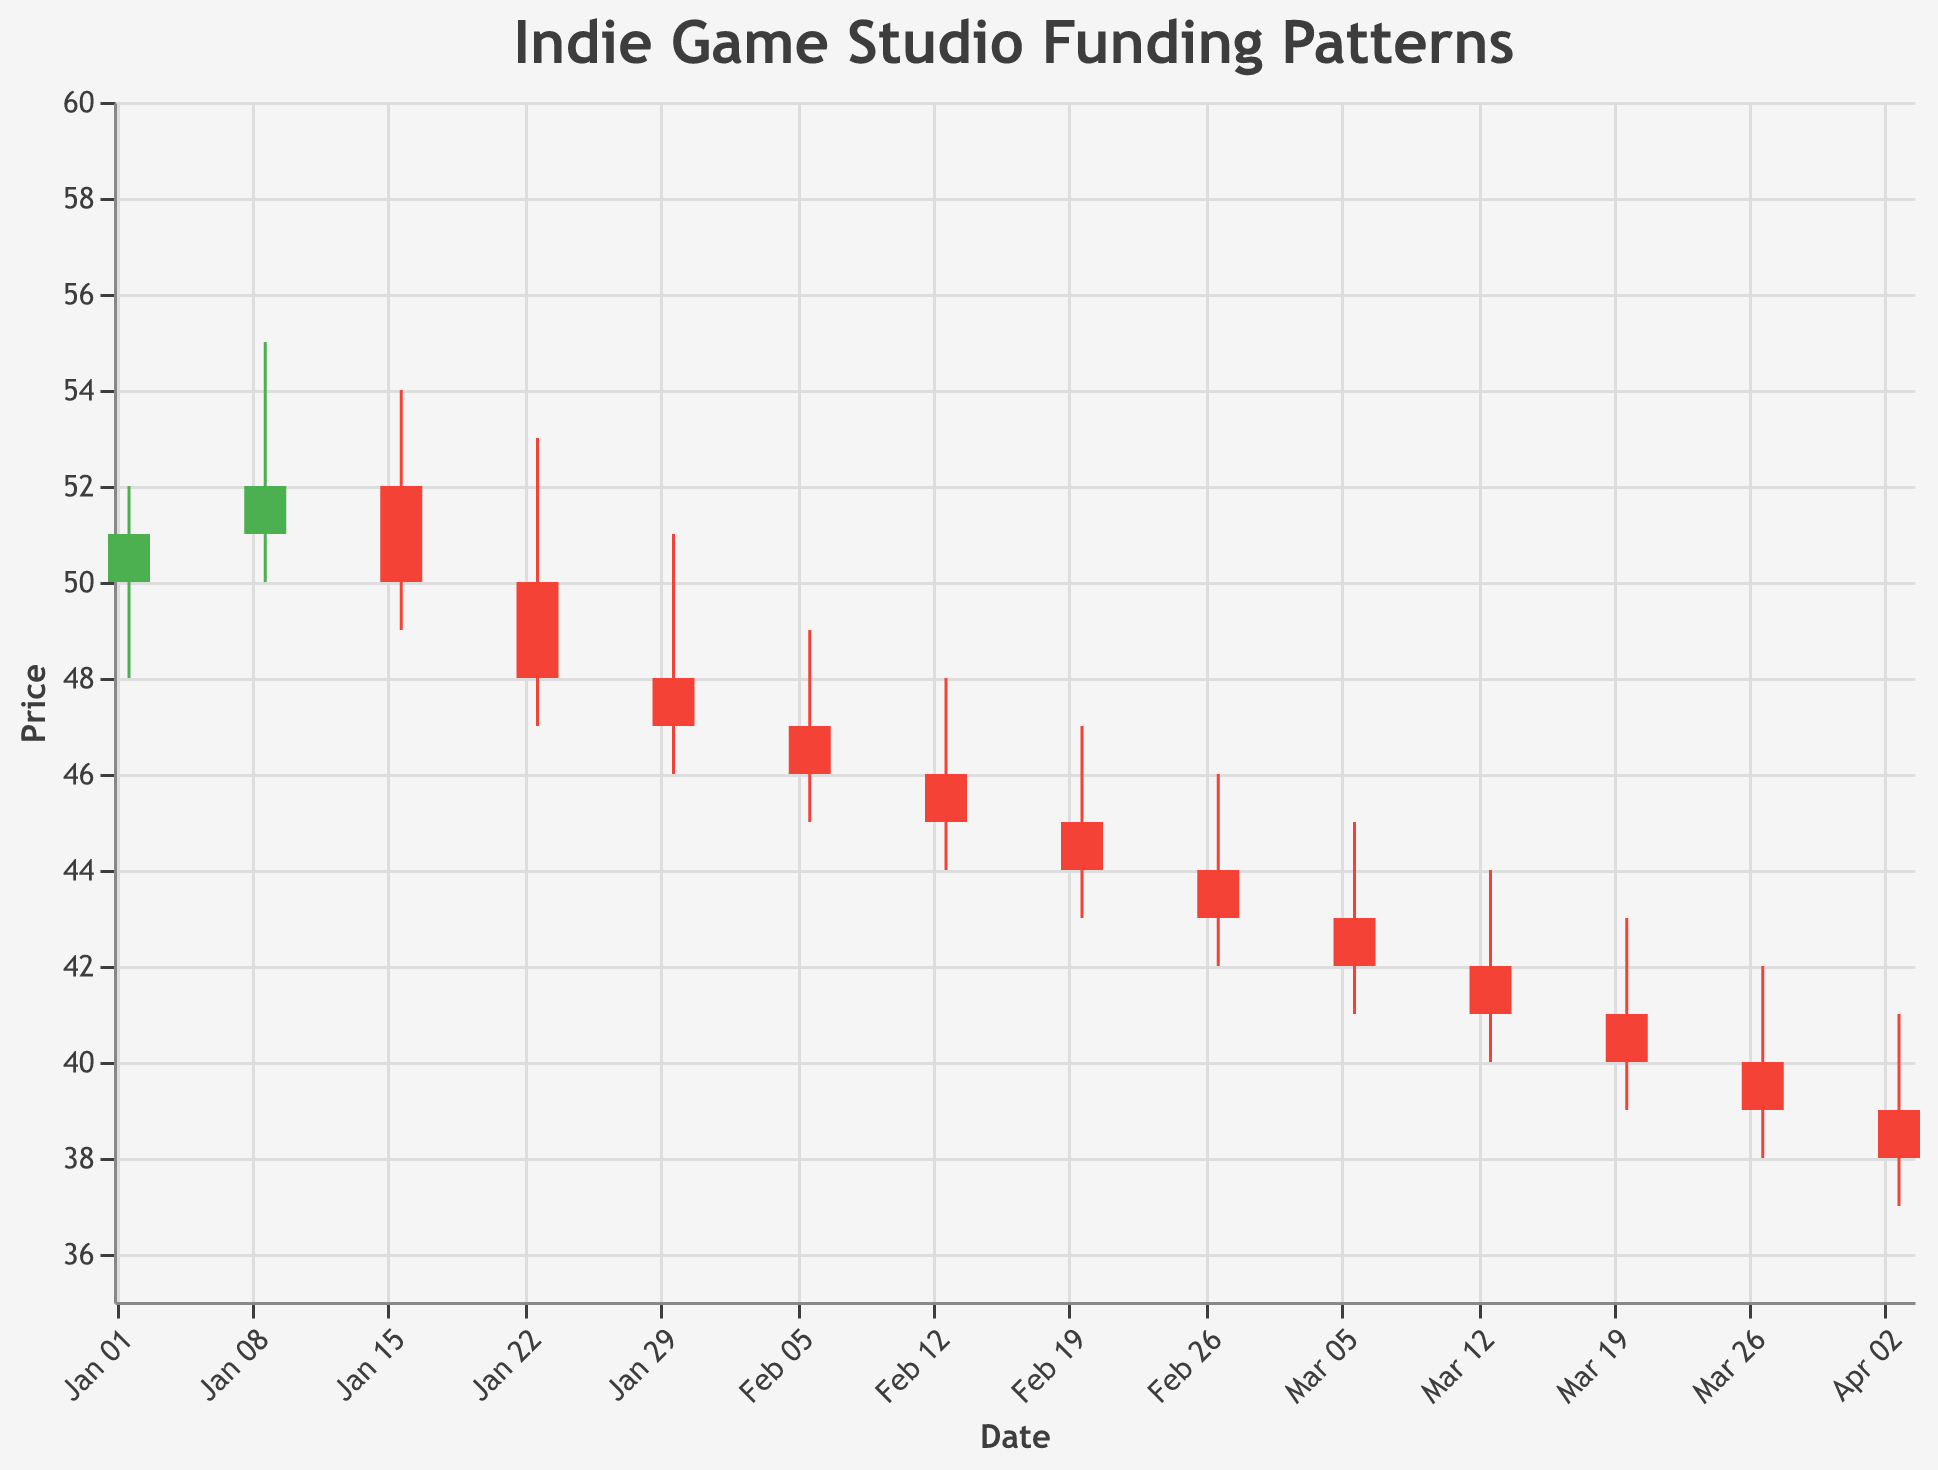What is the title of the figure? The title is displayed text at the top of the figure. It reads "Indie Game Studio Funding Patterns."
Answer: Indie Game Studio Funding Patterns Which date had the highest stock price? The highest stock price is indicated by the top value of any candlestick's high point. The highest value is on 2023-01-09 with a high of 55.
Answer: 2023-01-09 What is the closing price on January 23, 2023? Locate the candlestick for January 23, 2023, and find the close value, which is indicated at the end of the red (falling) bar. The close value is 48.
Answer: 48 On which date did SkyBox Labs receive an investment from Tencent, and what was the stock price's opening value on that day? Locate the event labeled as "Investment from Tencent" under SkyBox Labs. The date is 2023-03-20, and the opening price is 41.
Answer: 2023-03-20, 41 What was the stock pattern in terms of opening and closing prices from January 30, 2023, to February 13, 2023? Extract data for January 30, February 6, and February 13:
- 2023-01-30: Open = 48, Close = 47
- 2023-02-06: Open = 47, Close = 46
- 2023-02-13: Open = 46, Close = 45
The pattern shows a consecutive decrease in both opening and closing prices over these weeks.
Answer: Opening and closing prices consecutively decreased Which event resulted in the highest trading volume, and what was the corresponding stock close price? The highest trading volume is 1800 on 2023-01-09 for the event "Early Access release of 'Hades II'". The closing price is 52.
Answer: Early Access release of "Hades II", 52 What is the smallest difference between the high and low prices within a given week, and which week did it occur? Calculate the high-low differences for each week:
- 2023-01-16: Difference = 54-49 = 5
- Other weeks have higher differences.
The smallest difference of 4 occurs on the week of 2023-02-20 (47-43=4).
Answer: 4, 2023-02-20 Which studio had a decrease in their stock price after a funding or investment event and what was the closing price? Locate the candlesticks with funding/investment events. Annapurna Interactive (Funding round led by Sequoia Capital on 2023-01-16) had a close value less than the open value.
The closing price for Annapurna Interactive was 50.
Answer: Annapurna Interactive, 50 